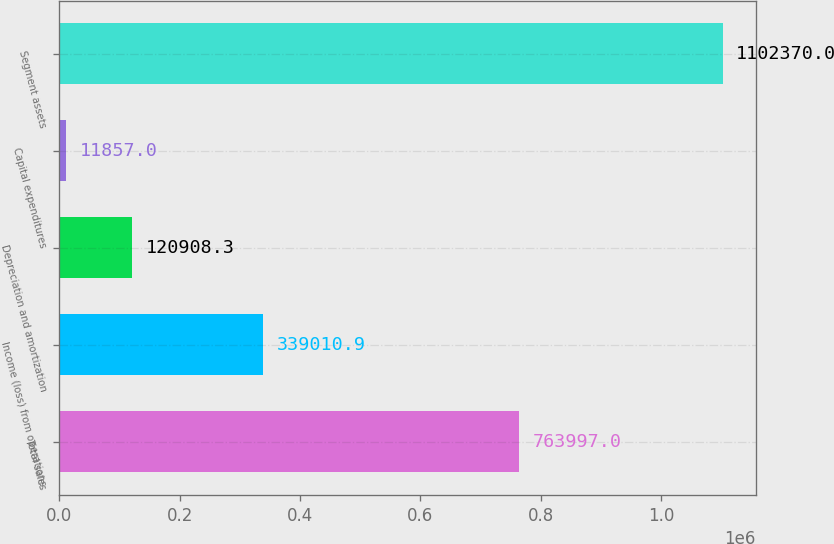<chart> <loc_0><loc_0><loc_500><loc_500><bar_chart><fcel>Total sales<fcel>Income (loss) from operations<fcel>Depreciation and amortization<fcel>Capital expenditures<fcel>Segment assets<nl><fcel>763997<fcel>339011<fcel>120908<fcel>11857<fcel>1.10237e+06<nl></chart> 